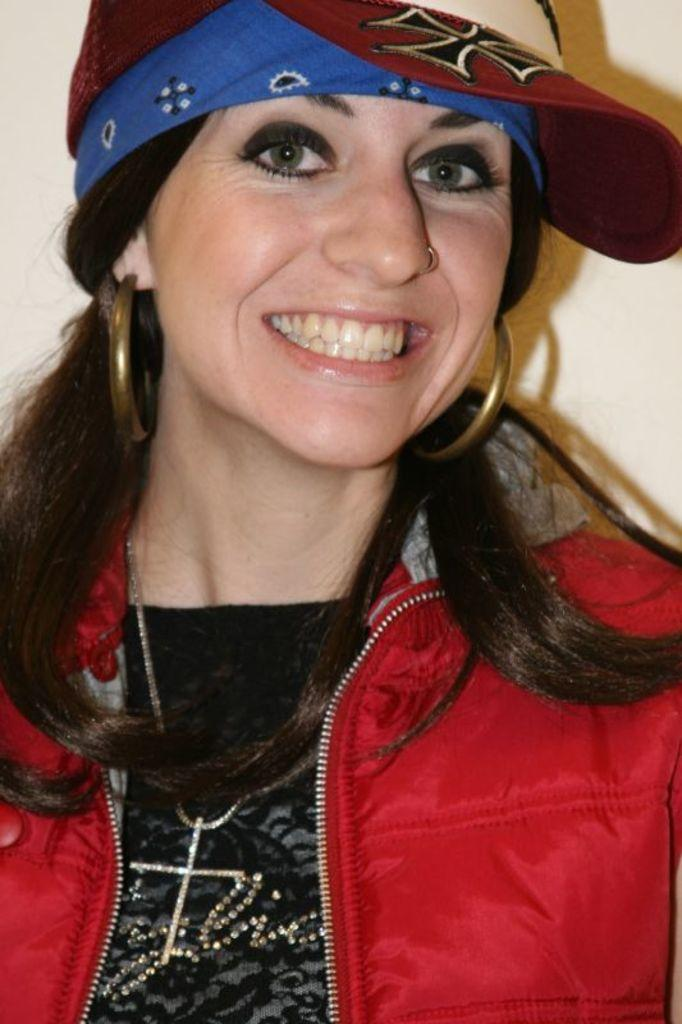Who or what is the main subject in the image? There is a person in the image. What is the person wearing? The person is wearing a red and black color dress. What can be seen behind the person in the image? The background of the image is cream-colored. What type of division is visible in the image? There is no division present in the image; it features a person wearing a dress in front of a cream-colored background. 